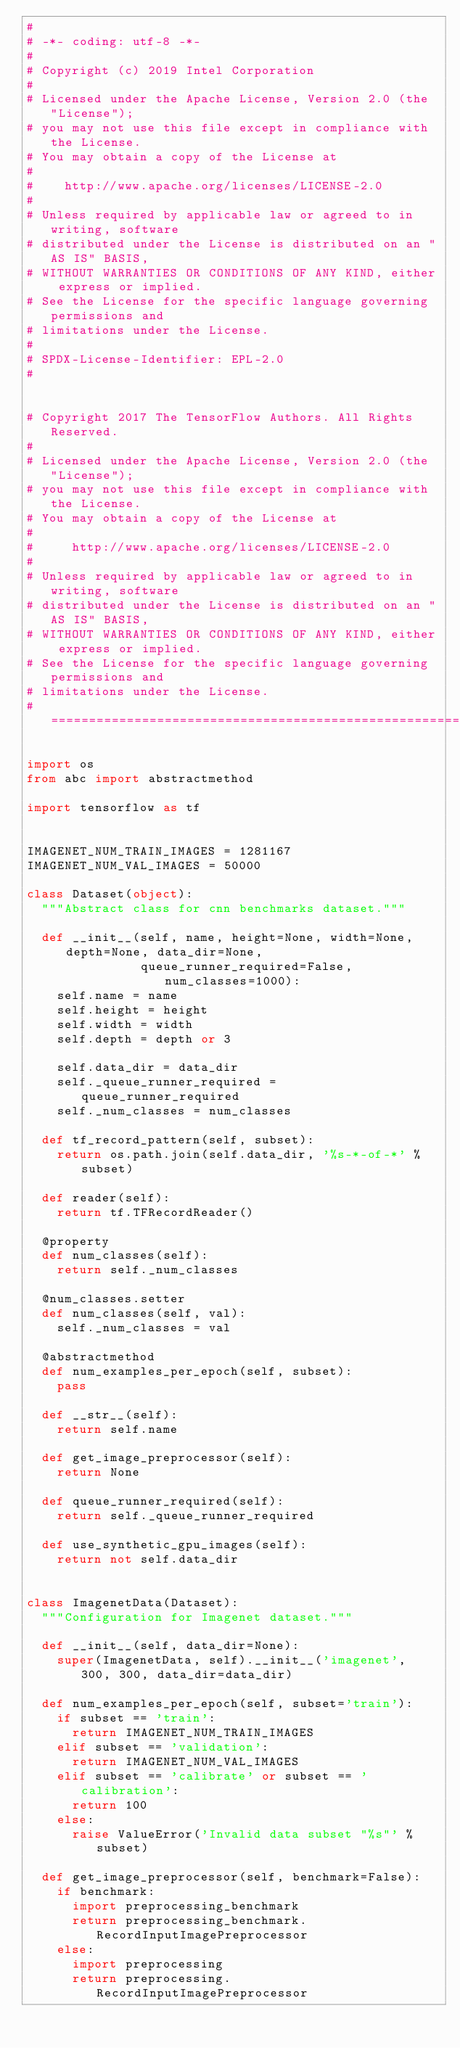Convert code to text. <code><loc_0><loc_0><loc_500><loc_500><_Python_>#
# -*- coding: utf-8 -*-
#
# Copyright (c) 2019 Intel Corporation
#
# Licensed under the Apache License, Version 2.0 (the "License");
# you may not use this file except in compliance with the License.
# You may obtain a copy of the License at
#
#    http://www.apache.org/licenses/LICENSE-2.0
#
# Unless required by applicable law or agreed to in writing, software
# distributed under the License is distributed on an "AS IS" BASIS,
# WITHOUT WARRANTIES OR CONDITIONS OF ANY KIND, either express or implied.
# See the License for the specific language governing permissions and
# limitations under the License.
#
# SPDX-License-Identifier: EPL-2.0
#


# Copyright 2017 The TensorFlow Authors. All Rights Reserved.
#
# Licensed under the Apache License, Version 2.0 (the "License");
# you may not use this file except in compliance with the License.
# You may obtain a copy of the License at
#
#     http://www.apache.org/licenses/LICENSE-2.0
#
# Unless required by applicable law or agreed to in writing, software
# distributed under the License is distributed on an "AS IS" BASIS,
# WITHOUT WARRANTIES OR CONDITIONS OF ANY KIND, either express or implied.
# See the License for the specific language governing permissions and
# limitations under the License.
# ==============================================================================

import os
from abc import abstractmethod

import tensorflow as tf


IMAGENET_NUM_TRAIN_IMAGES = 1281167
IMAGENET_NUM_VAL_IMAGES = 50000

class Dataset(object):
  """Abstract class for cnn benchmarks dataset."""

  def __init__(self, name, height=None, width=None, depth=None, data_dir=None,
               queue_runner_required=False, num_classes=1000):
    self.name = name
    self.height = height
    self.width = width
    self.depth = depth or 3

    self.data_dir = data_dir
    self._queue_runner_required = queue_runner_required
    self._num_classes = num_classes

  def tf_record_pattern(self, subset):
    return os.path.join(self.data_dir, '%s-*-of-*' % subset)

  def reader(self):
    return tf.TFRecordReader()

  @property
  def num_classes(self):
    return self._num_classes

  @num_classes.setter
  def num_classes(self, val):
    self._num_classes = val

  @abstractmethod
  def num_examples_per_epoch(self, subset):
    pass

  def __str__(self):
    return self.name

  def get_image_preprocessor(self):
    return None

  def queue_runner_required(self):
    return self._queue_runner_required

  def use_synthetic_gpu_images(self):
    return not self.data_dir


class ImagenetData(Dataset):
  """Configuration for Imagenet dataset."""

  def __init__(self, data_dir=None):
    super(ImagenetData, self).__init__('imagenet', 300, 300, data_dir=data_dir)

  def num_examples_per_epoch(self, subset='train'):
    if subset == 'train':
      return IMAGENET_NUM_TRAIN_IMAGES
    elif subset == 'validation':
      return IMAGENET_NUM_VAL_IMAGES
    elif subset == 'calibrate' or subset == 'calibration':
      return 100
    else:
      raise ValueError('Invalid data subset "%s"' % subset)

  def get_image_preprocessor(self, benchmark=False):
    if benchmark:
      import preprocessing_benchmark
      return preprocessing_benchmark.RecordInputImagePreprocessor
    else:
      import preprocessing
      return preprocessing.RecordInputImagePreprocessor

</code> 